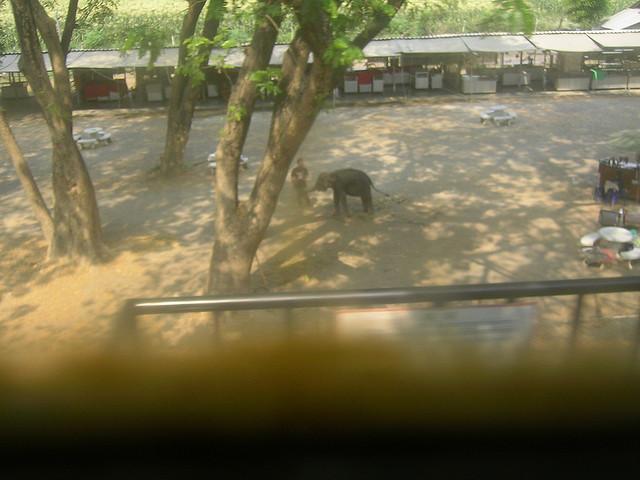Is the elephant in captivity?
Keep it brief. Yes. What is in the background in the photo?
Quick response, please. Baby elephant. What is covering the ground?
Write a very short answer. Dirt. 